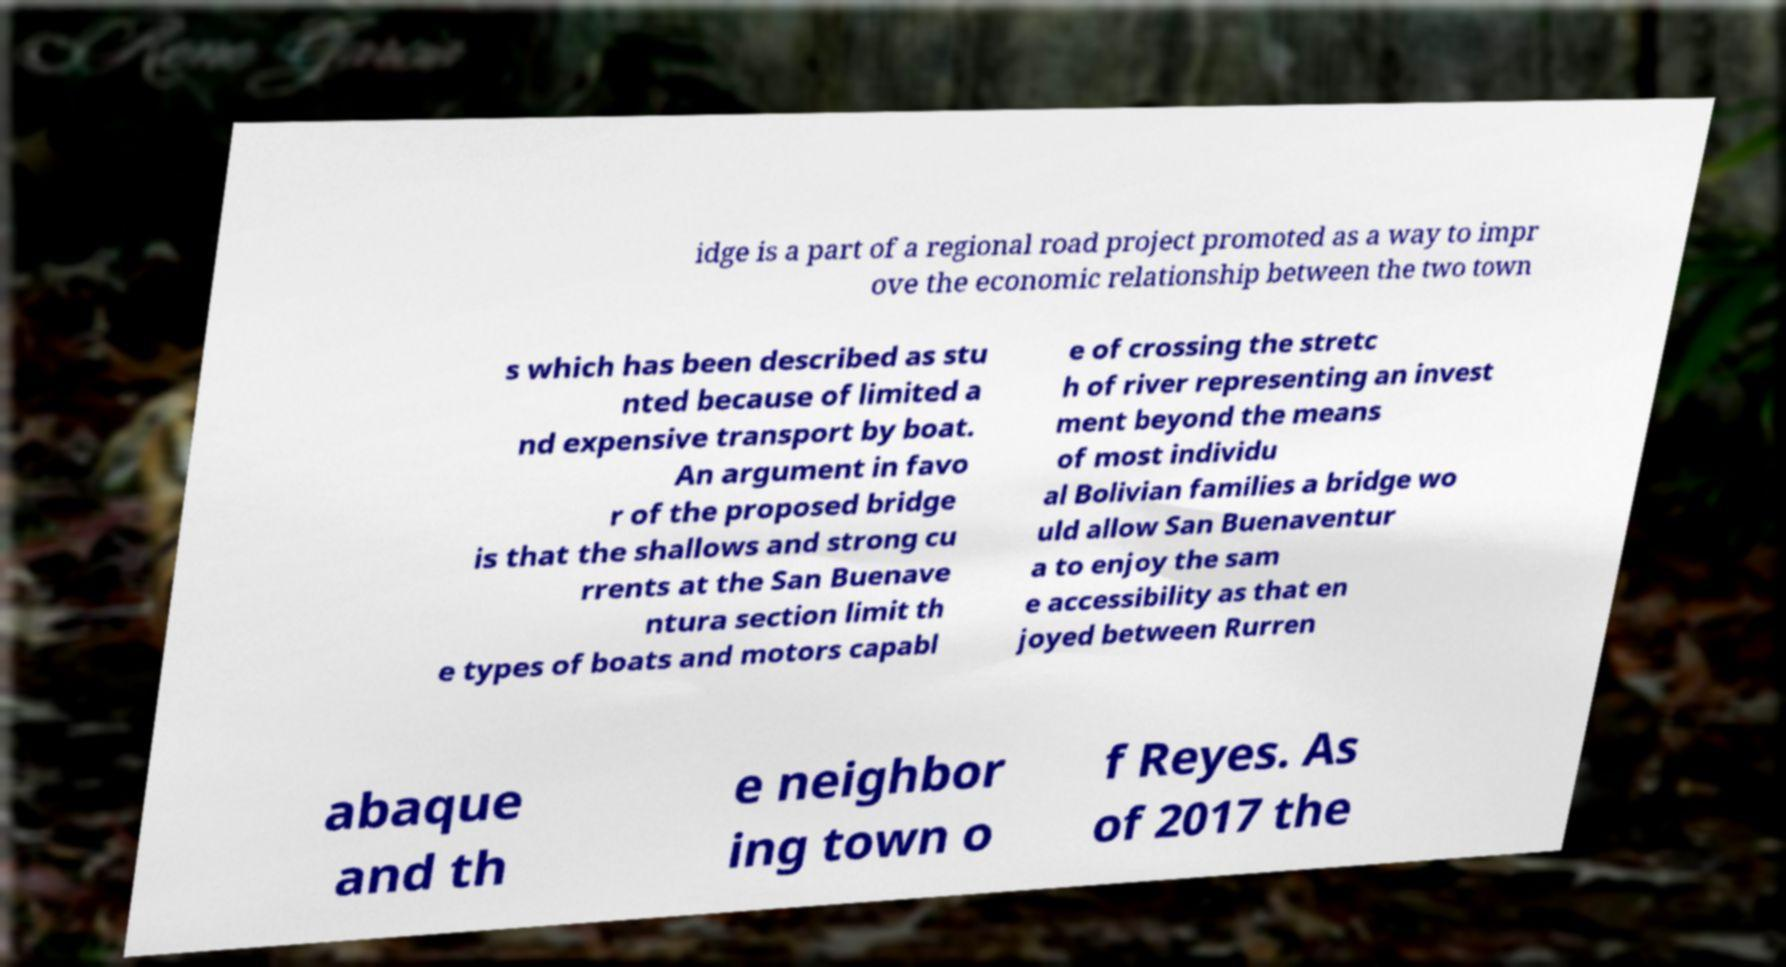Could you assist in decoding the text presented in this image and type it out clearly? idge is a part of a regional road project promoted as a way to impr ove the economic relationship between the two town s which has been described as stu nted because of limited a nd expensive transport by boat. An argument in favo r of the proposed bridge is that the shallows and strong cu rrents at the San Buenave ntura section limit th e types of boats and motors capabl e of crossing the stretc h of river representing an invest ment beyond the means of most individu al Bolivian families a bridge wo uld allow San Buenaventur a to enjoy the sam e accessibility as that en joyed between Rurren abaque and th e neighbor ing town o f Reyes. As of 2017 the 